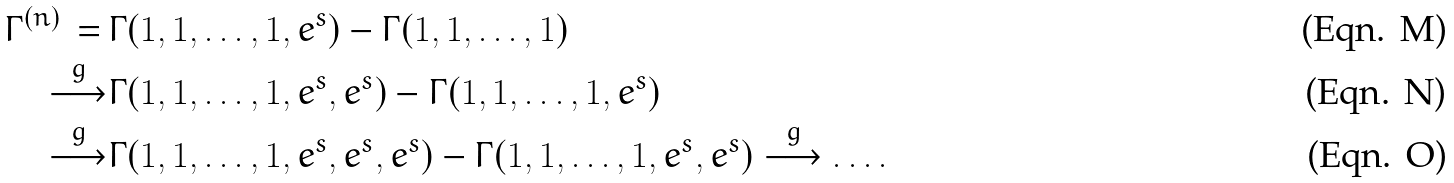Convert formula to latex. <formula><loc_0><loc_0><loc_500><loc_500>\Gamma ^ { ( n ) } \, = \, & \Gamma ( 1 , 1 , \dots , 1 , e ^ { s } ) - \Gamma ( 1 , 1 , \dots , 1 ) \\ \overset { g } { \longrightarrow } & \Gamma ( 1 , 1 , \dots , 1 , e ^ { s } , e ^ { s } ) - \Gamma ( 1 , 1 , \dots , 1 , e ^ { s } ) \\ \overset { g } { \longrightarrow } & \Gamma ( 1 , 1 , \dots , 1 , e ^ { s } , e ^ { s } , e ^ { s } ) - \Gamma ( 1 , 1 , \dots , 1 , e ^ { s } , e ^ { s } ) \overset { g } { \longrightarrow } \dots .</formula> 